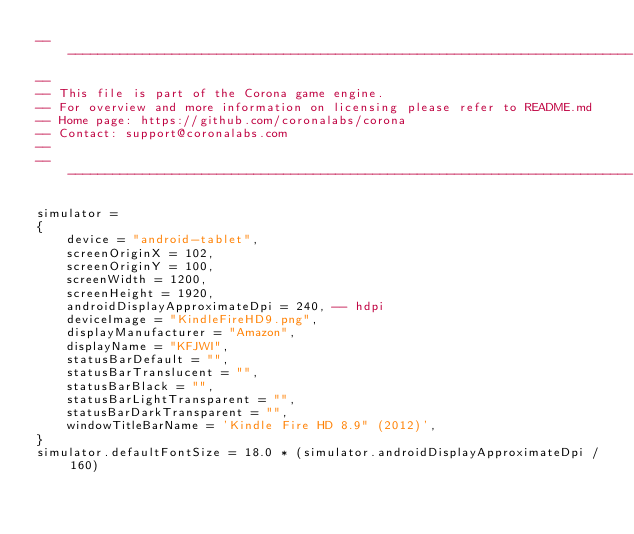Convert code to text. <code><loc_0><loc_0><loc_500><loc_500><_Lua_>------------------------------------------------------------------------------
--
-- This file is part of the Corona game engine.
-- For overview and more information on licensing please refer to README.md 
-- Home page: https://github.com/coronalabs/corona
-- Contact: support@coronalabs.com
--
------------------------------------------------------------------------------

simulator =
{
	device = "android-tablet",
	screenOriginX = 102,
	screenOriginY = 100,
	screenWidth = 1200,
	screenHeight = 1920,
	androidDisplayApproximateDpi = 240, -- hdpi
	deviceImage = "KindleFireHD9.png",
	displayManufacturer = "Amazon",
	displayName = "KFJWI",
	statusBarDefault = "", 
	statusBarTranslucent = "", 
	statusBarBlack = "", 
	statusBarLightTransparent = "",
	statusBarDarkTransparent = "",
	windowTitleBarName = 'Kindle Fire HD 8.9" (2012)',
}
simulator.defaultFontSize = 18.0 * (simulator.androidDisplayApproximateDpi / 160)
</code> 